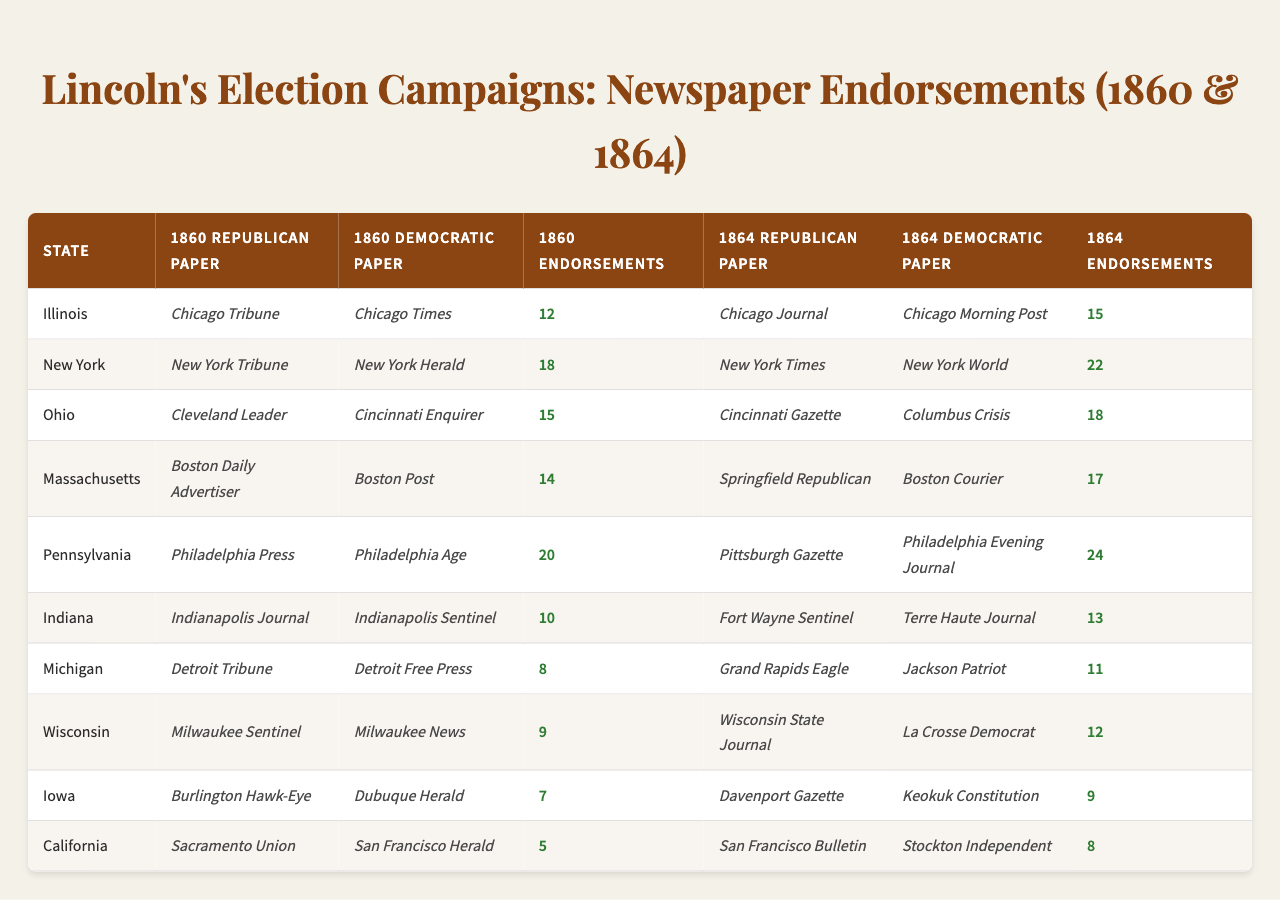What is the total number of endorsements for Lincoln in 1860? To find the total endorsements for Lincoln in 1860, we need to sum up the values in the "1860 Lincoln Endorsements" column: 12 + 18 + 15 + 14 + 20 + 10 + 8 + 9 + 7 + 5 = 118.
Answer: 118 Which state had the most Republican newspaper endorsements for Lincoln in 1864? In the "1864 Endorsements" column, the values are: 15 (Illinois), 22 (New York), 18 (Ohio), 17 (Massachusetts), 24 (Pennsylvania), 13 (Indiana), 11 (Michigan), 12 (Wisconsin), 9 (Iowa), and 8 (California). The highest value is 24 from Pennsylvania.
Answer: Pennsylvania Did Illinois have more endorsements for Lincoln in 1860 or 1864? Illinois had 12 endorsements in 1860 and 15 in 1864. Since 15 is greater than 12, Illinois had more endorsements in 1864.
Answer: Yes What is the average number of endorsements for Lincoln in 1864 across the states? To calculate the average for Lincoln's endorsements in 1864, we sum the values: 15 + 22 + 18 + 17 + 24 + 13 + 11 + 12 + 9 + 8 =  18.8. We then divide by 10 (the number of states): 188/10 = 18.8.
Answer: 18.8 Which Democratic paper in New York existed in 1860? From the "1860 Democratic Papers" column, the paper listed for New York is the "New York Herald."
Answer: New York Herald What is the difference in the number of Lincoln endorsements between Ohio in 1860 and 1864? For Ohio, Lincoln received 15 endorsements in 1860 and 18 endorsements in 1864. To find the difference: 18 - 15 = 3 endorsements more in 1864.
Answer: 3 Which state had more Republican endorsements in 1860 than in 1864? To find this out, we compare the endorsements: Illinois (12, 15), New York (18, 22), Ohio (15, 18), Massachusetts (14, 17), Pennsylvania (20, 24), Indiana (10, 13), Michigan (8, 11), Wisconsin (9, 12), Iowa (7, 9), and California (5, 8). None had more in 1860 than in 1864. Therefore, every state had more or the same number of endorsements in 1864.
Answer: No What was the total number of Democratic newspaper endorsements in California across both elections? In 1860, California had 10 endorsements from the "San Francisco Herald," and there were no endorsements noted for Democrats in 1864 in the data. Thus, the total is 10.
Answer: 10 Which state's Republican papers had the fewest endorsements for Lincoln in 1860? In the "1860 Lincoln Endorsements" column, the values show that California had the least endorsements with 5.
Answer: California How many more Democratic newspapers supported Lincoln in 1860 compared to 1864? The number of Democratic papers in 1860 is 10 and in 1864 is also 10. The difference is 10 - 10 = 0, thus the number supported is the same.
Answer: 0 